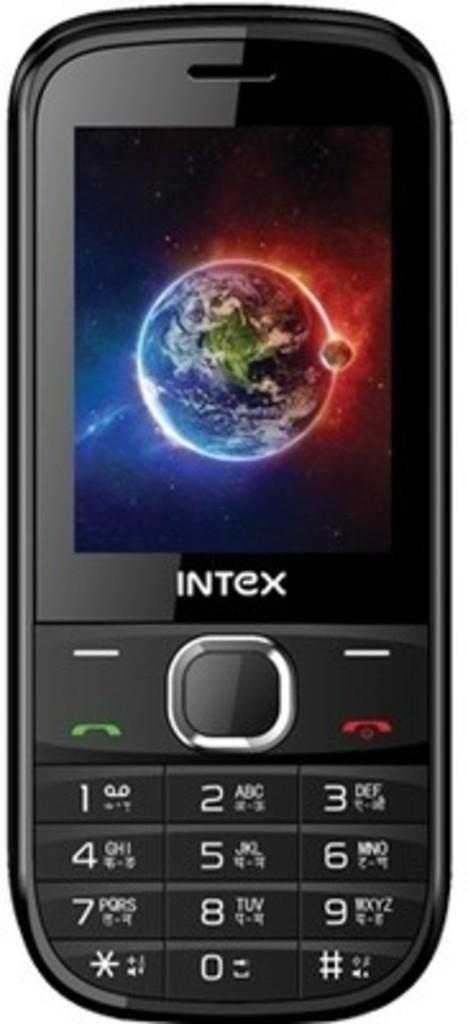<image>
Render a clear and concise summary of the photo. an Intex phone with a few numbers on it 